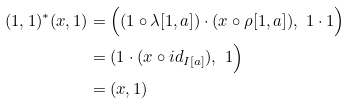<formula> <loc_0><loc_0><loc_500><loc_500>( 1 , 1 ) ^ { * } ( x , 1 ) & = \Big ( ( 1 \circ \lambda [ 1 , a ] ) \cdot ( x \circ \rho [ 1 , a ] ) , \ 1 \cdot 1 \Big ) \\ & = ( 1 \cdot ( x \circ { i d } _ { I [ a ] } ) , \ 1 \Big ) \\ & = ( x , 1 )</formula> 